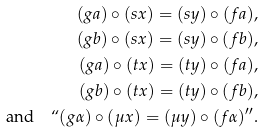Convert formula to latex. <formula><loc_0><loc_0><loc_500><loc_500>( g a ) \circ ( s x ) = ( s y ) \circ ( f a ) , \\ ( g b ) \circ ( s x ) = ( s y ) \circ ( f b ) , \\ ( g a ) \circ ( t x ) = ( t y ) \circ ( f a ) , \\ ( g b ) \circ ( t x ) = ( t y ) \circ ( f b ) , \\ \text {and} \quad ` ` ( g \alpha ) \circ ( \mu x ) = ( \mu y ) \circ ( f \alpha ) ^ { \prime \prime } .</formula> 